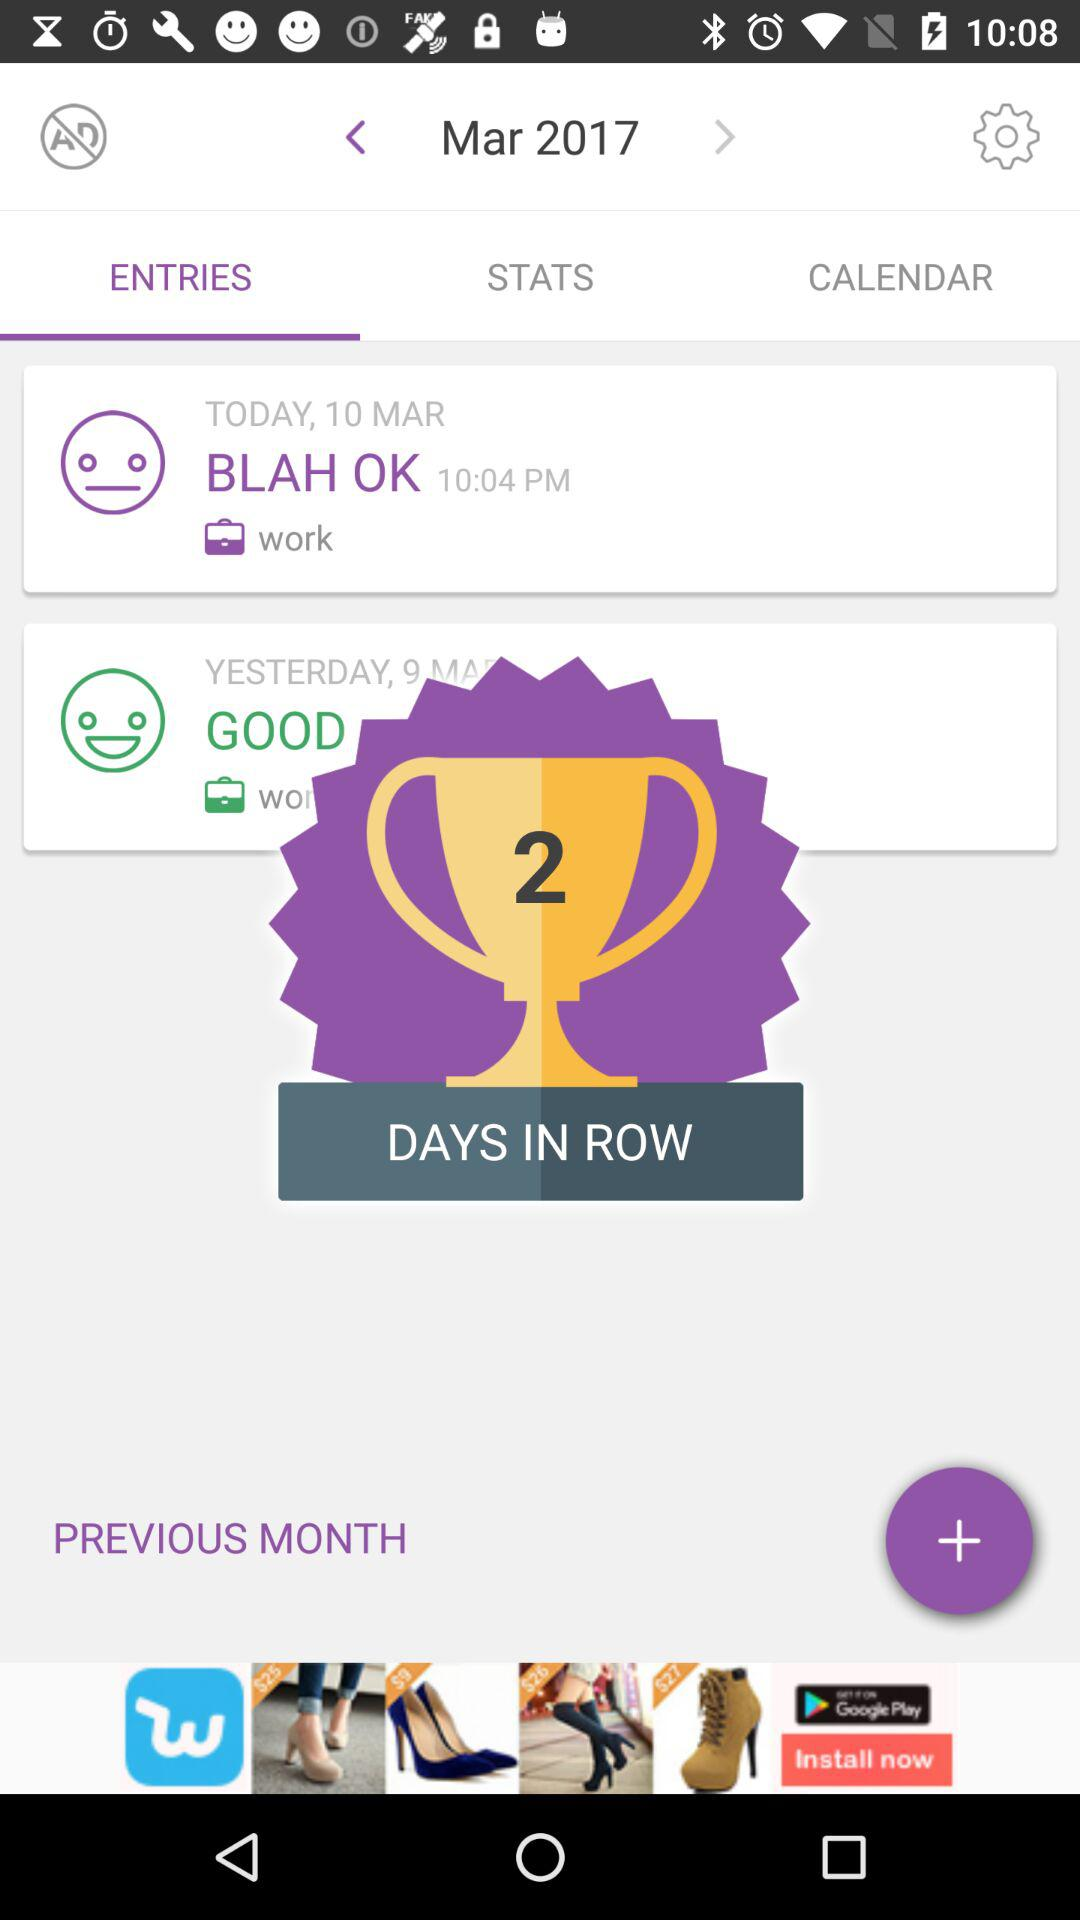How many entries are there on the screen?
Answer the question using a single word or phrase. 2 